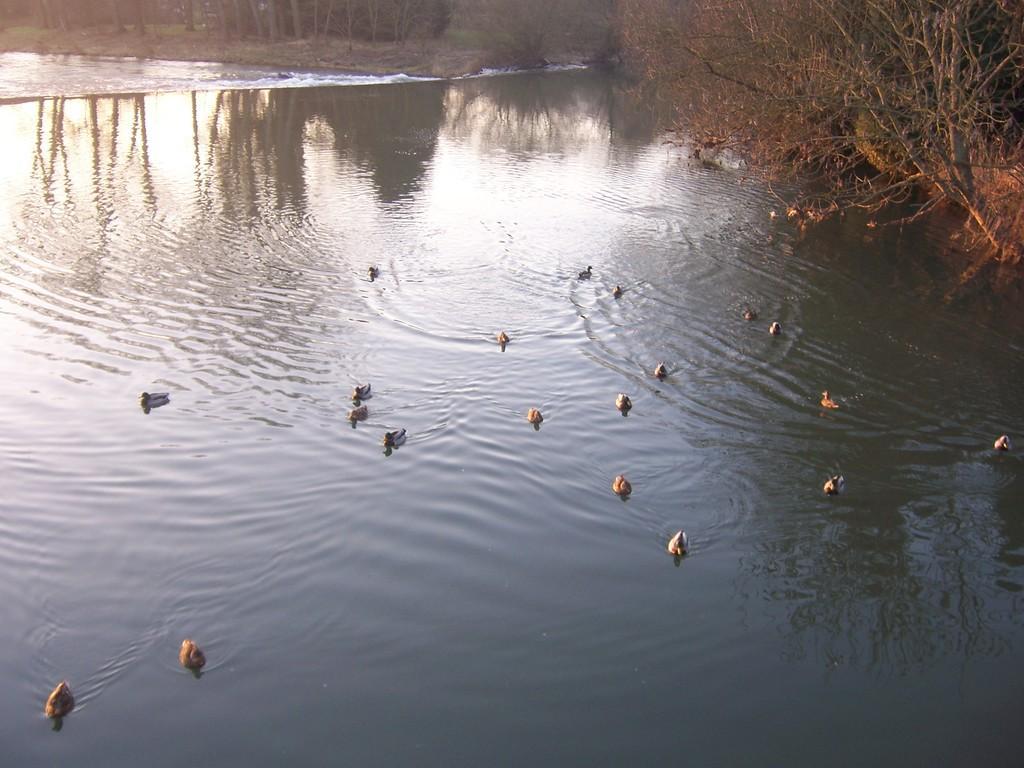Describe this image in one or two sentences. In this image there are birds in the water and there are trees. 